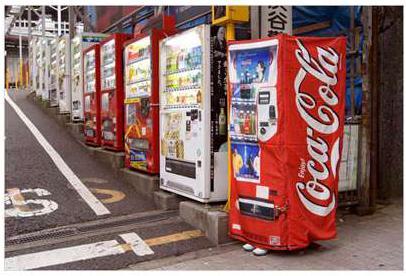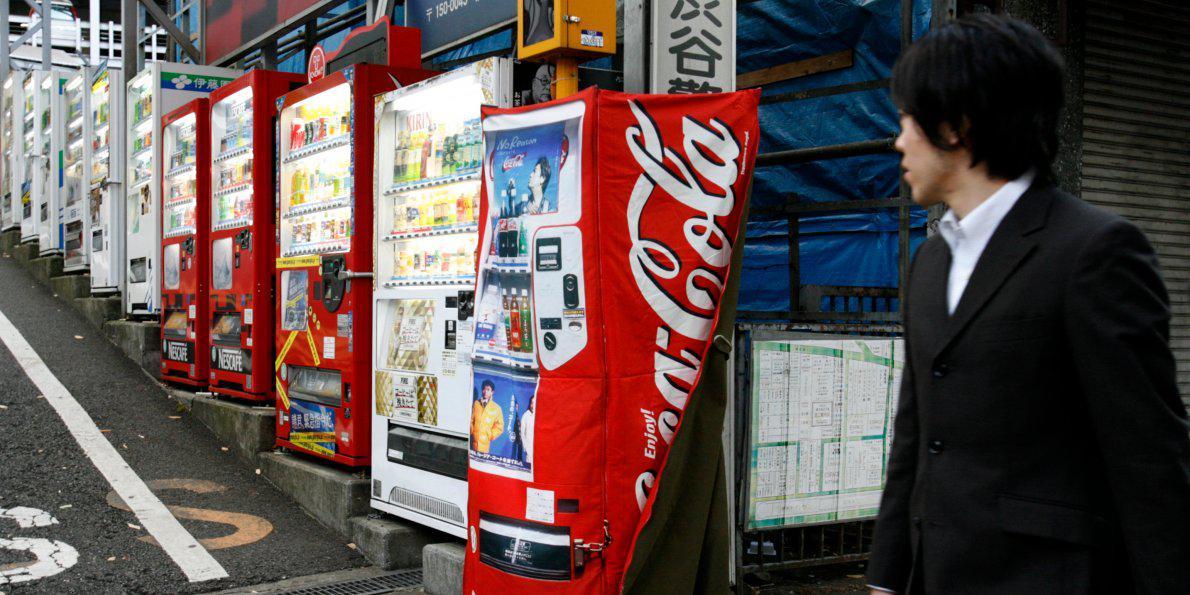The first image is the image on the left, the second image is the image on the right. For the images displayed, is the sentence "there is a person in one of the iamges." factually correct? Answer yes or no. Yes. The first image is the image on the left, the second image is the image on the right. For the images shown, is this caption "A dark-haired young man in a suit jacket is in the right of one image." true? Answer yes or no. Yes. 